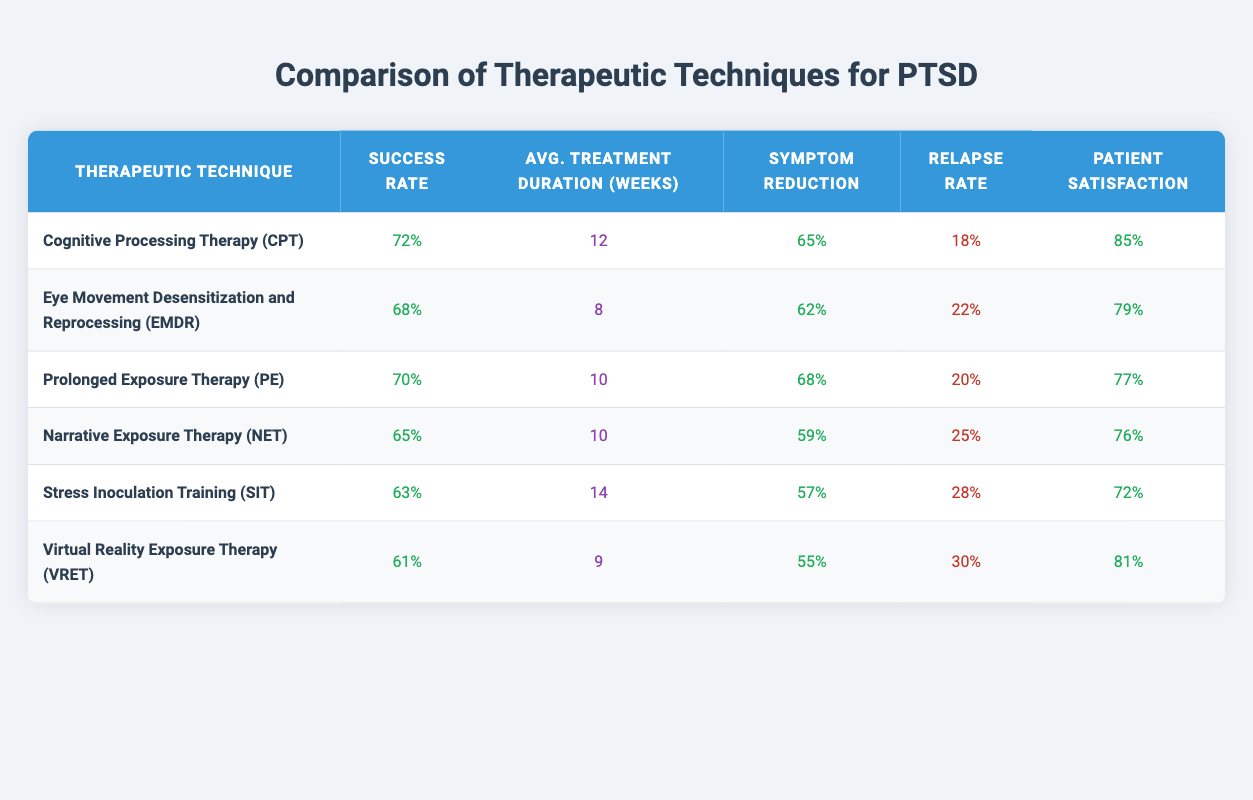What is the success rate of Cognitive Processing Therapy (CPT)? The table shows the success rate for Cognitive Processing Therapy (CPT) as 72%.
Answer: 72% Which therapeutic technique has the highest patient satisfaction? By comparing the patient satisfaction rates, Cognitive Processing Therapy (CPT) has a patient satisfaction of 85%, which is the highest among the listed techniques.
Answer: Cognitive Processing Therapy (CPT) How many weeks, on average, does Stress Inoculation Training (SIT) take? According to the table, the average treatment duration for Stress Inoculation Training (SIT) is 14 weeks.
Answer: 14 weeks What is the difference in success rates between Eye Movement Desensitization and Reprocessing (EMDR) and Prolonged Exposure Therapy (PE)? The success rate for EMDR is 68% and for PE it is 70%. The difference is calculated as 70% - 68%, which equals 2%.
Answer: 2% Is the relapse rate lower for Cognitive Processing Therapy (CPT) compared to Narrative Exposure Therapy (NET)? CPT has a relapse rate of 18% while NET's relapse rate is 25%. Since 18% is less than 25%, the statement is true.
Answer: Yes What is the average symptom reduction across all techniques listed? To find the average symptom reduction, we sum the individual symptom reductions (65 + 62 + 68 + 59 + 57 + 55 = 366) and divide by the number of techniques (6). The average is 366 / 6 = 61%.
Answer: 61% Which technique has a higher relapse rate, Virtual Reality Exposure Therapy (VRET) or Cognitive Processing Therapy (CPT)? VRET has a relapse rate of 30% while CPT's rate is 18%. Since 30% is greater than 18%, VRET has a higher relapse rate.
Answer: Virtual Reality Exposure Therapy (VRET) Are the average treatment durations for all techniques less than 15 weeks? The table provides average treatment durations of 12 weeks for CPT, 8 weeks for EMDR, 10 weeks for PE, 10 weeks for NET, 14 weeks for SIT, and 9 weeks for VRET. Since SIT takes 14 weeks, all techniques meet the condition.
Answer: Yes What therapeutic intervention has the lowest success rate, and what is that rate? By examining the success rates, Stress Inoculation Training has the lowest success rate at 63%.
Answer: 63% 